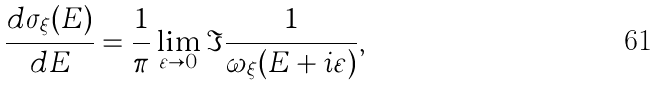Convert formula to latex. <formula><loc_0><loc_0><loc_500><loc_500>\frac { d \sigma _ { \xi } ( E ) } { d E } = \frac { 1 } { \pi } \lim _ { \varepsilon \rightarrow 0 } \Im \frac { 1 } { \omega _ { \xi } ( E + i \varepsilon ) } ,</formula> 